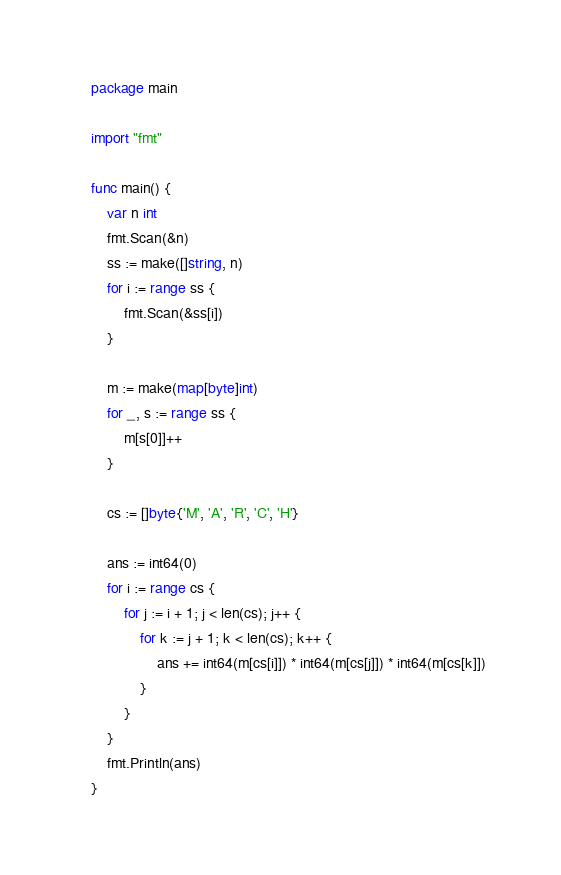<code> <loc_0><loc_0><loc_500><loc_500><_Go_>package main

import "fmt"

func main() {
	var n int
	fmt.Scan(&n)
	ss := make([]string, n)
	for i := range ss {
		fmt.Scan(&ss[i])
	}

	m := make(map[byte]int)
	for _, s := range ss {
		m[s[0]]++
	}

	cs := []byte{'M', 'A', 'R', 'C', 'H'}

	ans := int64(0)
	for i := range cs {
		for j := i + 1; j < len(cs); j++ {
			for k := j + 1; k < len(cs); k++ {
				ans += int64(m[cs[i]]) * int64(m[cs[j]]) * int64(m[cs[k]])
			}
		}
	}
	fmt.Println(ans)
}
</code> 